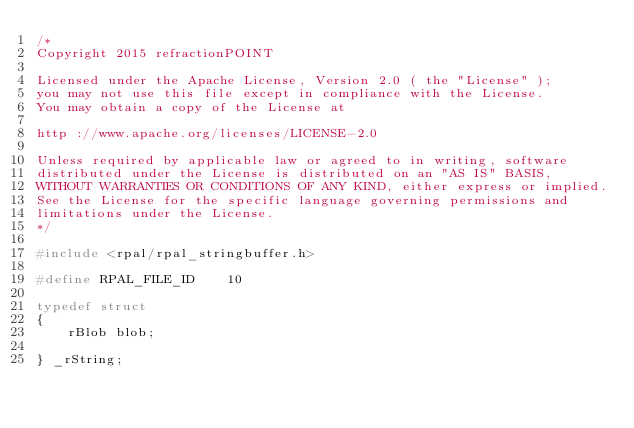<code> <loc_0><loc_0><loc_500><loc_500><_C_>/*
Copyright 2015 refractionPOINT

Licensed under the Apache License, Version 2.0 ( the "License" );
you may not use this file except in compliance with the License.
You may obtain a copy of the License at

http ://www.apache.org/licenses/LICENSE-2.0

Unless required by applicable law or agreed to in writing, software
distributed under the License is distributed on an "AS IS" BASIS,
WITHOUT WARRANTIES OR CONDITIONS OF ANY KIND, either express or implied.
See the License for the specific language governing permissions and
limitations under the License.
*/

#include <rpal/rpal_stringbuffer.h>

#define RPAL_FILE_ID    10

typedef struct
{
    rBlob blob;

} _rString;
</code> 